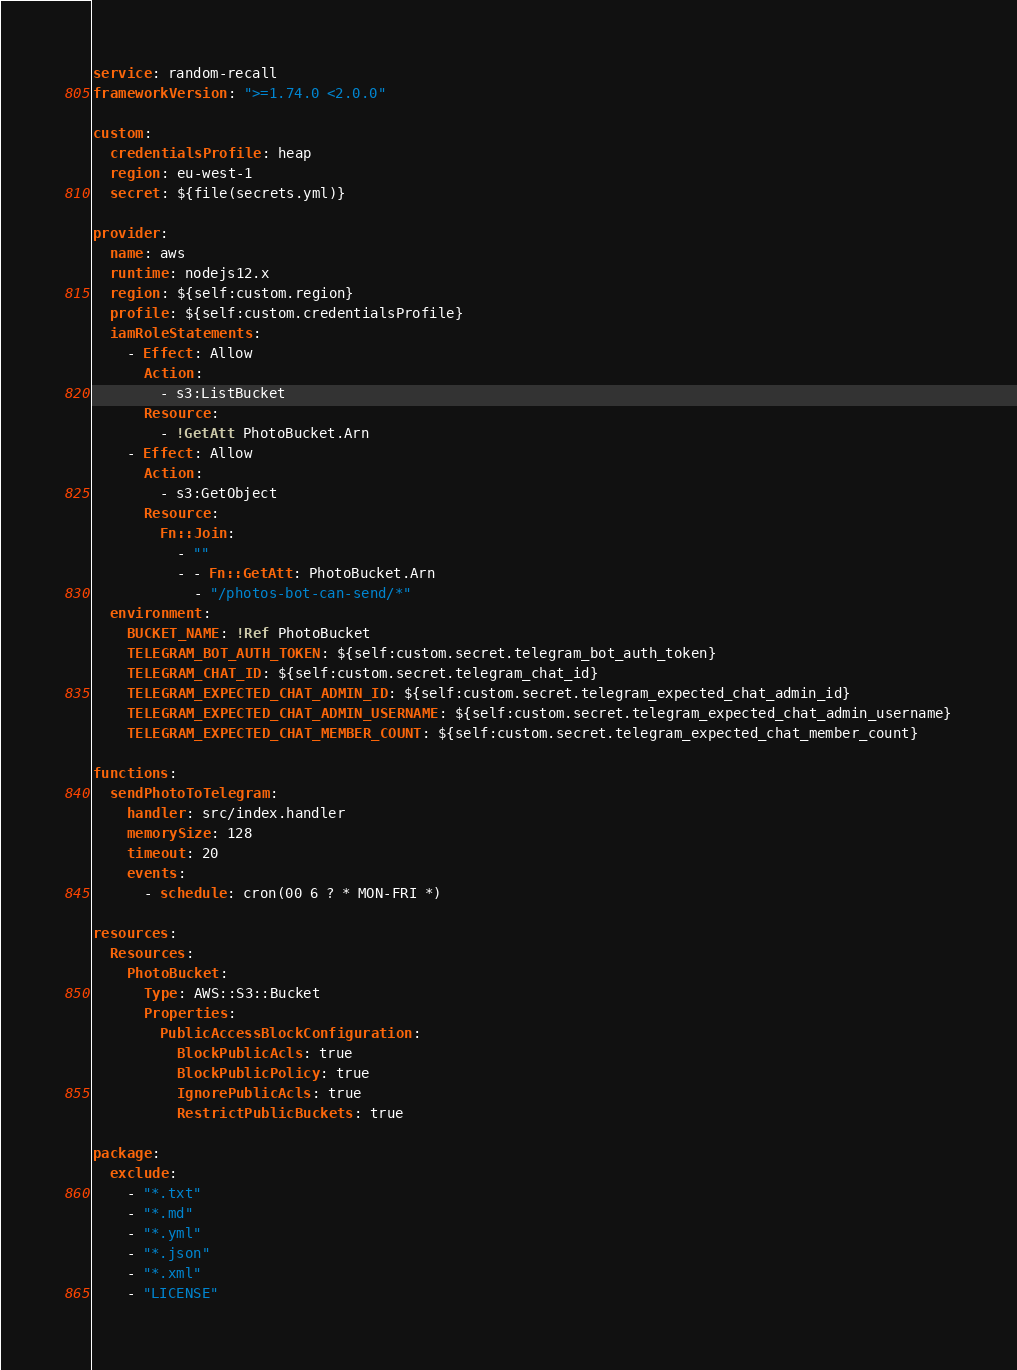<code> <loc_0><loc_0><loc_500><loc_500><_YAML_>service: random-recall
frameworkVersion: ">=1.74.0 <2.0.0"

custom:
  credentialsProfile: heap
  region: eu-west-1
  secret: ${file(secrets.yml)}

provider:
  name: aws
  runtime: nodejs12.x
  region: ${self:custom.region}
  profile: ${self:custom.credentialsProfile}
  iamRoleStatements:
    - Effect: Allow
      Action:
        - s3:ListBucket
      Resource:
        - !GetAtt PhotoBucket.Arn
    - Effect: Allow
      Action:
        - s3:GetObject
      Resource:
        Fn::Join:
          - ""
          - - Fn::GetAtt: PhotoBucket.Arn
            - "/photos-bot-can-send/*"
  environment:
    BUCKET_NAME: !Ref PhotoBucket
    TELEGRAM_BOT_AUTH_TOKEN: ${self:custom.secret.telegram_bot_auth_token}
    TELEGRAM_CHAT_ID: ${self:custom.secret.telegram_chat_id}
    TELEGRAM_EXPECTED_CHAT_ADMIN_ID: ${self:custom.secret.telegram_expected_chat_admin_id}
    TELEGRAM_EXPECTED_CHAT_ADMIN_USERNAME: ${self:custom.secret.telegram_expected_chat_admin_username}
    TELEGRAM_EXPECTED_CHAT_MEMBER_COUNT: ${self:custom.secret.telegram_expected_chat_member_count}

functions:
  sendPhotoToTelegram:
    handler: src/index.handler
    memorySize: 128
    timeout: 20
    events:
      - schedule: cron(00 6 ? * MON-FRI *)

resources:
  Resources:
    PhotoBucket:
      Type: AWS::S3::Bucket
      Properties:
        PublicAccessBlockConfiguration:
          BlockPublicAcls: true
          BlockPublicPolicy: true
          IgnorePublicAcls: true
          RestrictPublicBuckets: true

package:
  exclude:
    - "*.txt"
    - "*.md"
    - "*.yml"
    - "*.json"
    - "*.xml"
    - "LICENSE"
</code> 